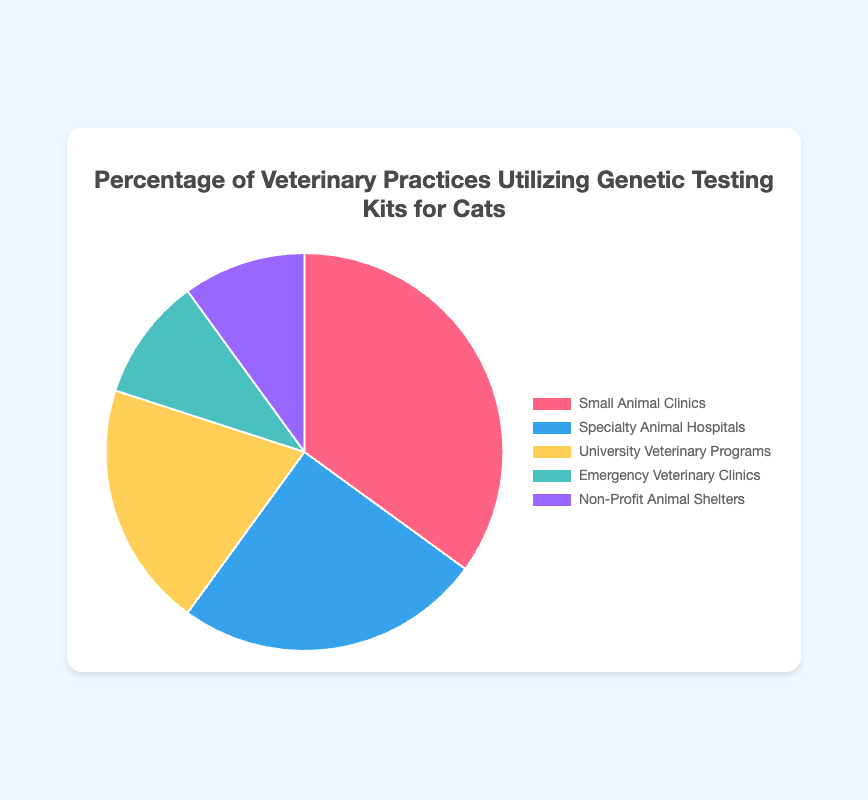What percentage of the total practices are Small Animal Clinics and Specialty Animal Hospitals combined? Combine the percentages for Small Animal Clinics (35%) and Specialty Animal Hospitals (25%) by adding them: 35 + 25 = 60
Answer: 60 Which practice type has the lowest usage of genetic testing kits? Compare the percentages of all practice types and identify the smallest value. Both Emergency Veterinary Clinics and Non-Profit Animal Shelters have the lowest percentages at 10% each
Answer: Emergency Veterinary Clinics and Non-Profit Animal Shelters How much higher is the percentage of Small Animal Clinics using genetic testing than University Veterinary Programs? Subtract the percentage of University Veterinary Programs (20%) from Small Animal Clinics (35%): 35 - 20 = 15
Answer: 15 Which practice type utilizes genetic testing kits more: Specialty Animal Hospitals or University Veterinary Programs? Compare the percentages of Specialty Animal Hospitals (25%) and University Veterinary Programs (20%). The higher percentage is for Specialty Animal Hospitals
Answer: Specialty Animal Hospitals What's the total percentage of practices not classified as Small Animal Clinics or Specialty Animal Hospitals? Add the percentages for University Veterinary Programs (20%), Emergency Veterinary Clinics (10%), and Non-Profit Animal Shelters (10%): 20 + 10 + 10 = 40
Answer: 40 What is the difference in the percentage of practices using genetic testing kits between Small Animal Clinics and Emergency Veterinary Clinics? Subtract the percentage of Emergency Veterinary Clinics (10%) from Small Animal Clinics (35%): 35 - 10 = 25
Answer: 25 What color represents Non-Profit Animal Shelters in the pie chart? Identify the color of the sector for Non-Profit Animal Shelters, which is described visually in the chart's legend. It is purple
Answer: purple Is the percentage of practices using genetic testing kits for Specialty Animal Hospitals less than 30%? Compare the percentage of Specialty Animal Hospitals (25%) with 30%; 25% is less than 30%
Answer: Yes What fraction of the practices utilizing genetic testing kits are University Veterinary Programs? Convert the percentage of University Veterinary Programs (20%) to a fraction: 20/100 = 1/5
Answer: 1/5 